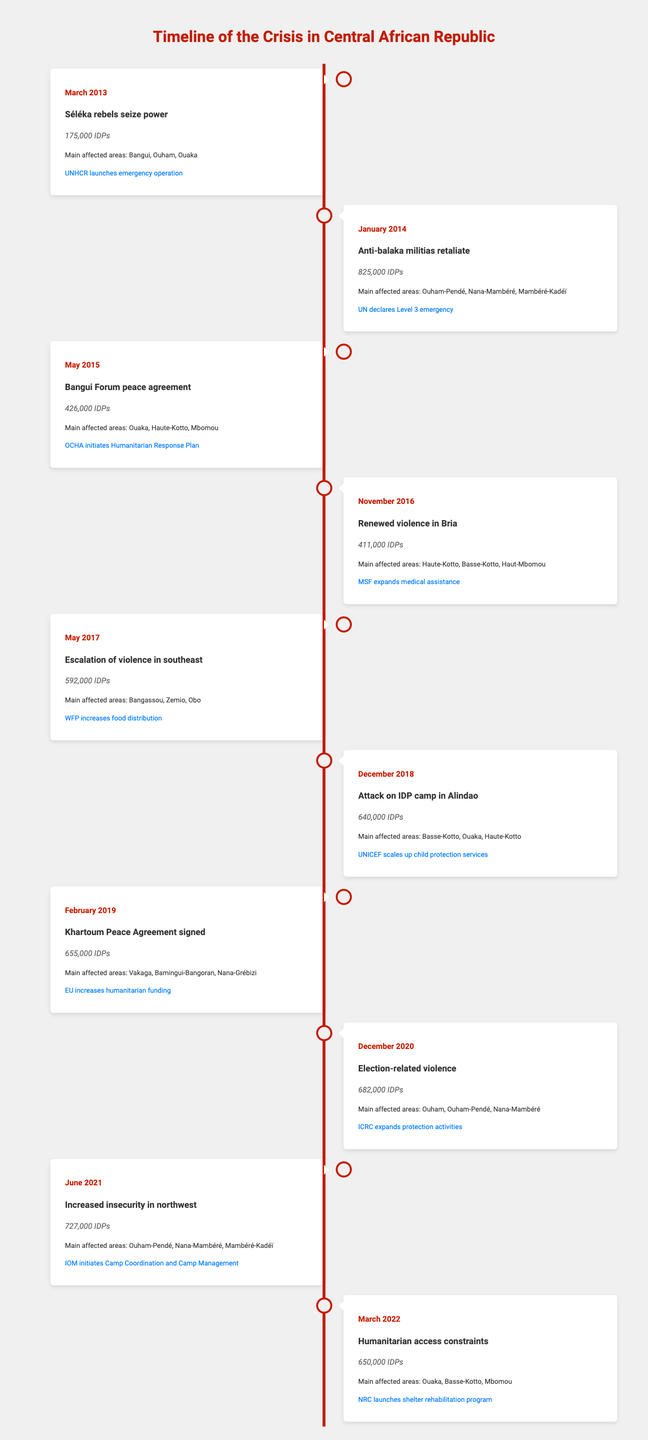What was the IDP count in January 2014? From the table, in January 2014, the IDP count is specifically listed as 825,000.
Answer: 825,000 Which event led to the highest number of IDPs? By comparing the IDP counts across all events, the event that led to the highest number of IDPs is the Anti-balaka militias retaliate in January 2014, with 825,000 IDPs.
Answer: Anti-balaka militias retaliate Is the IDP count higher in 2021 than in 2013? In 2021, the IDP count is 727,000, and in 2013, it is 175,000. Thus, 727,000 is greater than 175,000, confirming that the IDP count is higher in 2021.
Answer: Yes What is the difference in the IDP count between the events in March 2013 and November 2016? The IDP count in March 2013 is 175,000 and in November 2016 is 411,000. The difference is 411,000 - 175,000 = 236,000.
Answer: 236,000 What were the main affected areas during the December 2018 event? According to the table, the main affected areas during the attack on the IDP camp in Alindao in December 2018 were Basse-Kotto, Ouaka, and Haute-Kotto.
Answer: Basse-Kotto, Ouaka, Haute-Kotto Did the IDP count increase from February 2019 to December 2020? In February 2019, the IDP count is 655,000 and in December 2020 it is 682,000; since 682,000 is greater than 655,000, this indicates an increase in IDPs.
Answer: Yes What percentage of the IDP count in May 2015 does the IDP count in March 2022 represent? The IDP count in May 2015 is 426,000 and in March 2022 it is 650,000. To find the percentage: (650,000 / 426,000) * 100 = 152.5%. Therefore, the IDP count in March 2022 represents about 152.5% of that in May 2015.
Answer: 152.5% Which event saw an increase in humanitarian funding, and what was the IDP count at that time? The Khartoum Peace Agreement signed in February 2019 saw an increase in humanitarian funding, and the IDP count at that time was 655,000.
Answer: 655,000 What was the average IDP count from 2013 to 2022? To find the average, sum the IDP counts from each year: 175,000 + 825,000 + 426,000 + 411,000 + 592,000 + 640,000 + 655,000 + 682,000 + 727,000 + 650,000 = 4,982,000. Then divide by the number of events (10): 4,982,000 / 10 = 498,200.
Answer: 498,200 